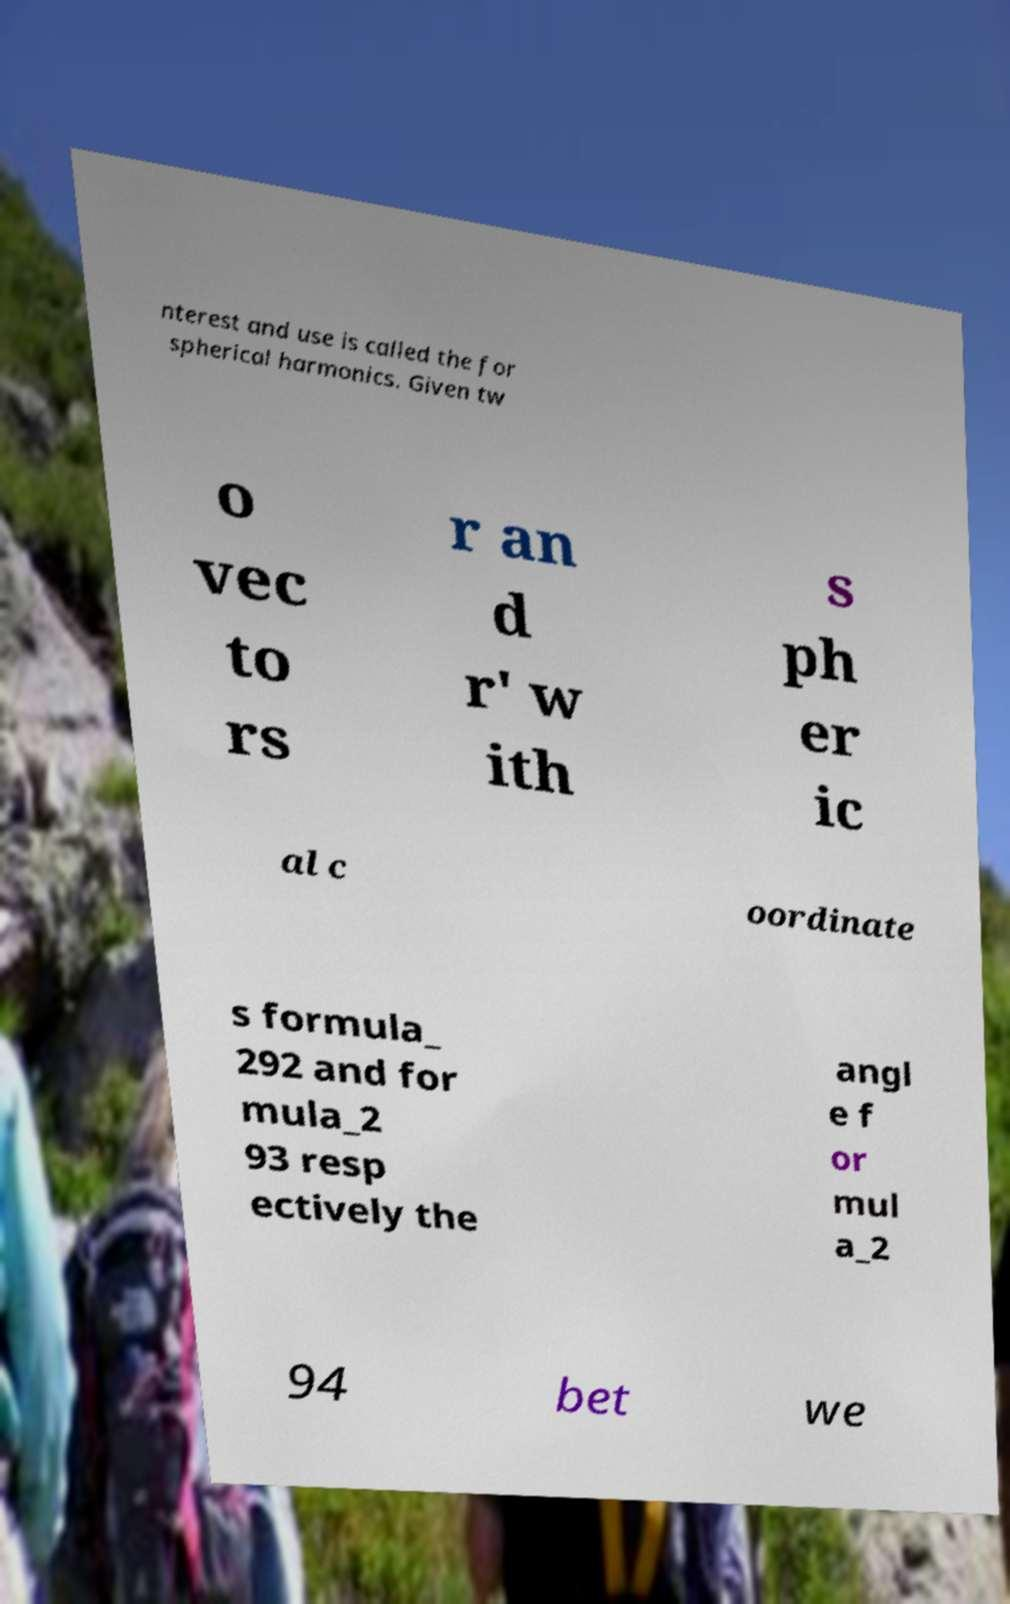Can you read and provide the text displayed in the image?This photo seems to have some interesting text. Can you extract and type it out for me? nterest and use is called the for spherical harmonics. Given tw o vec to rs r an d r' w ith s ph er ic al c oordinate s formula_ 292 and for mula_2 93 resp ectively the angl e f or mul a_2 94 bet we 